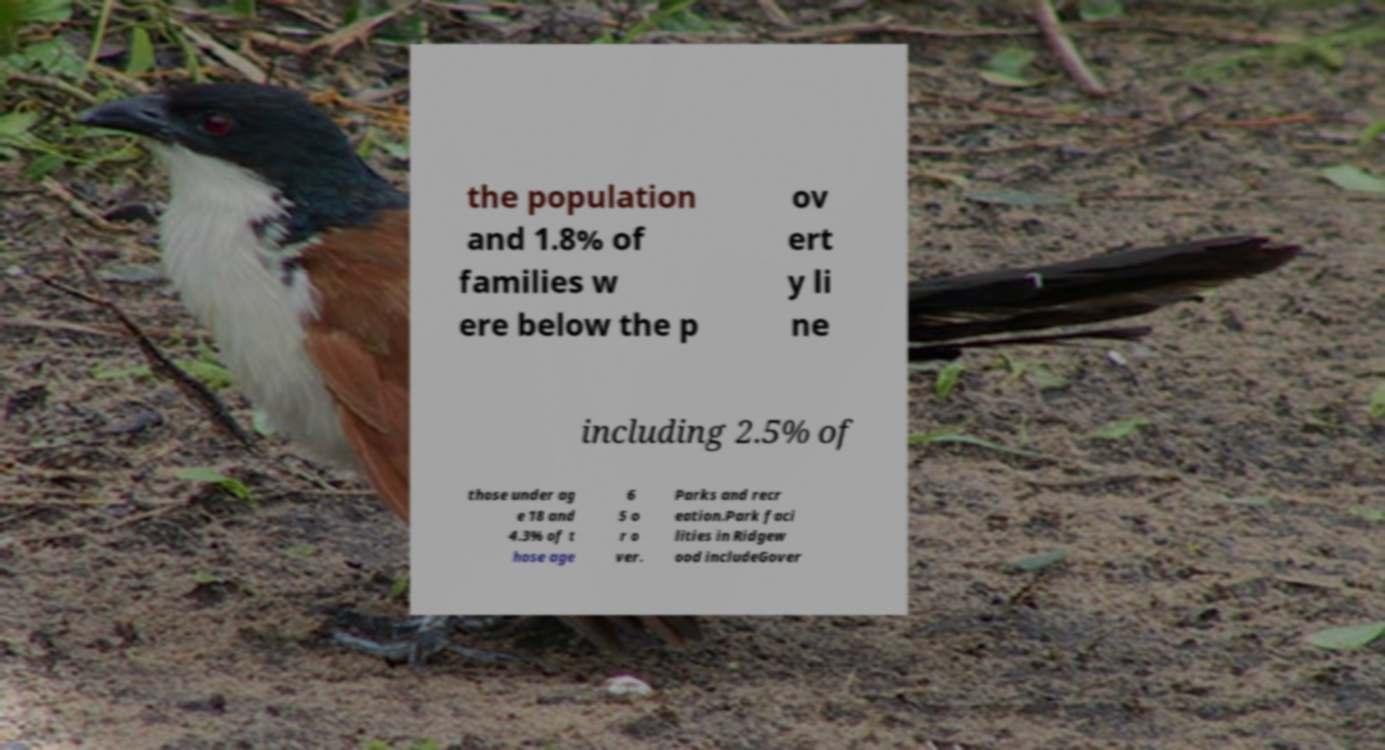Can you accurately transcribe the text from the provided image for me? the population and 1.8% of families w ere below the p ov ert y li ne including 2.5% of those under ag e 18 and 4.3% of t hose age 6 5 o r o ver. Parks and recr eation.Park faci lities in Ridgew ood includeGover 